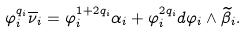Convert formula to latex. <formula><loc_0><loc_0><loc_500><loc_500>\varphi _ { i } ^ { q _ { i } } \overline { \nu } _ { i } = \varphi _ { i } ^ { 1 + 2 q _ { i } } \alpha _ { i } + \varphi _ { i } ^ { 2 q _ { i } } d \varphi _ { i } \wedge \widetilde { \beta } _ { i } .</formula> 